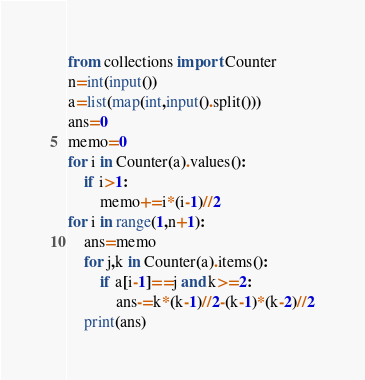Convert code to text. <code><loc_0><loc_0><loc_500><loc_500><_Python_>from collections import Counter
n=int(input())
a=list(map(int,input().split()))
ans=0
memo=0
for i in Counter(a).values():
	if i>1:
		memo+=i*(i-1)//2
for i in range(1,n+1):
	ans=memo
	for j,k in Counter(a).items():
		if a[i-1]==j and k>=2:
			ans-=k*(k-1)//2-(k-1)*(k-2)//2
	print(ans)</code> 